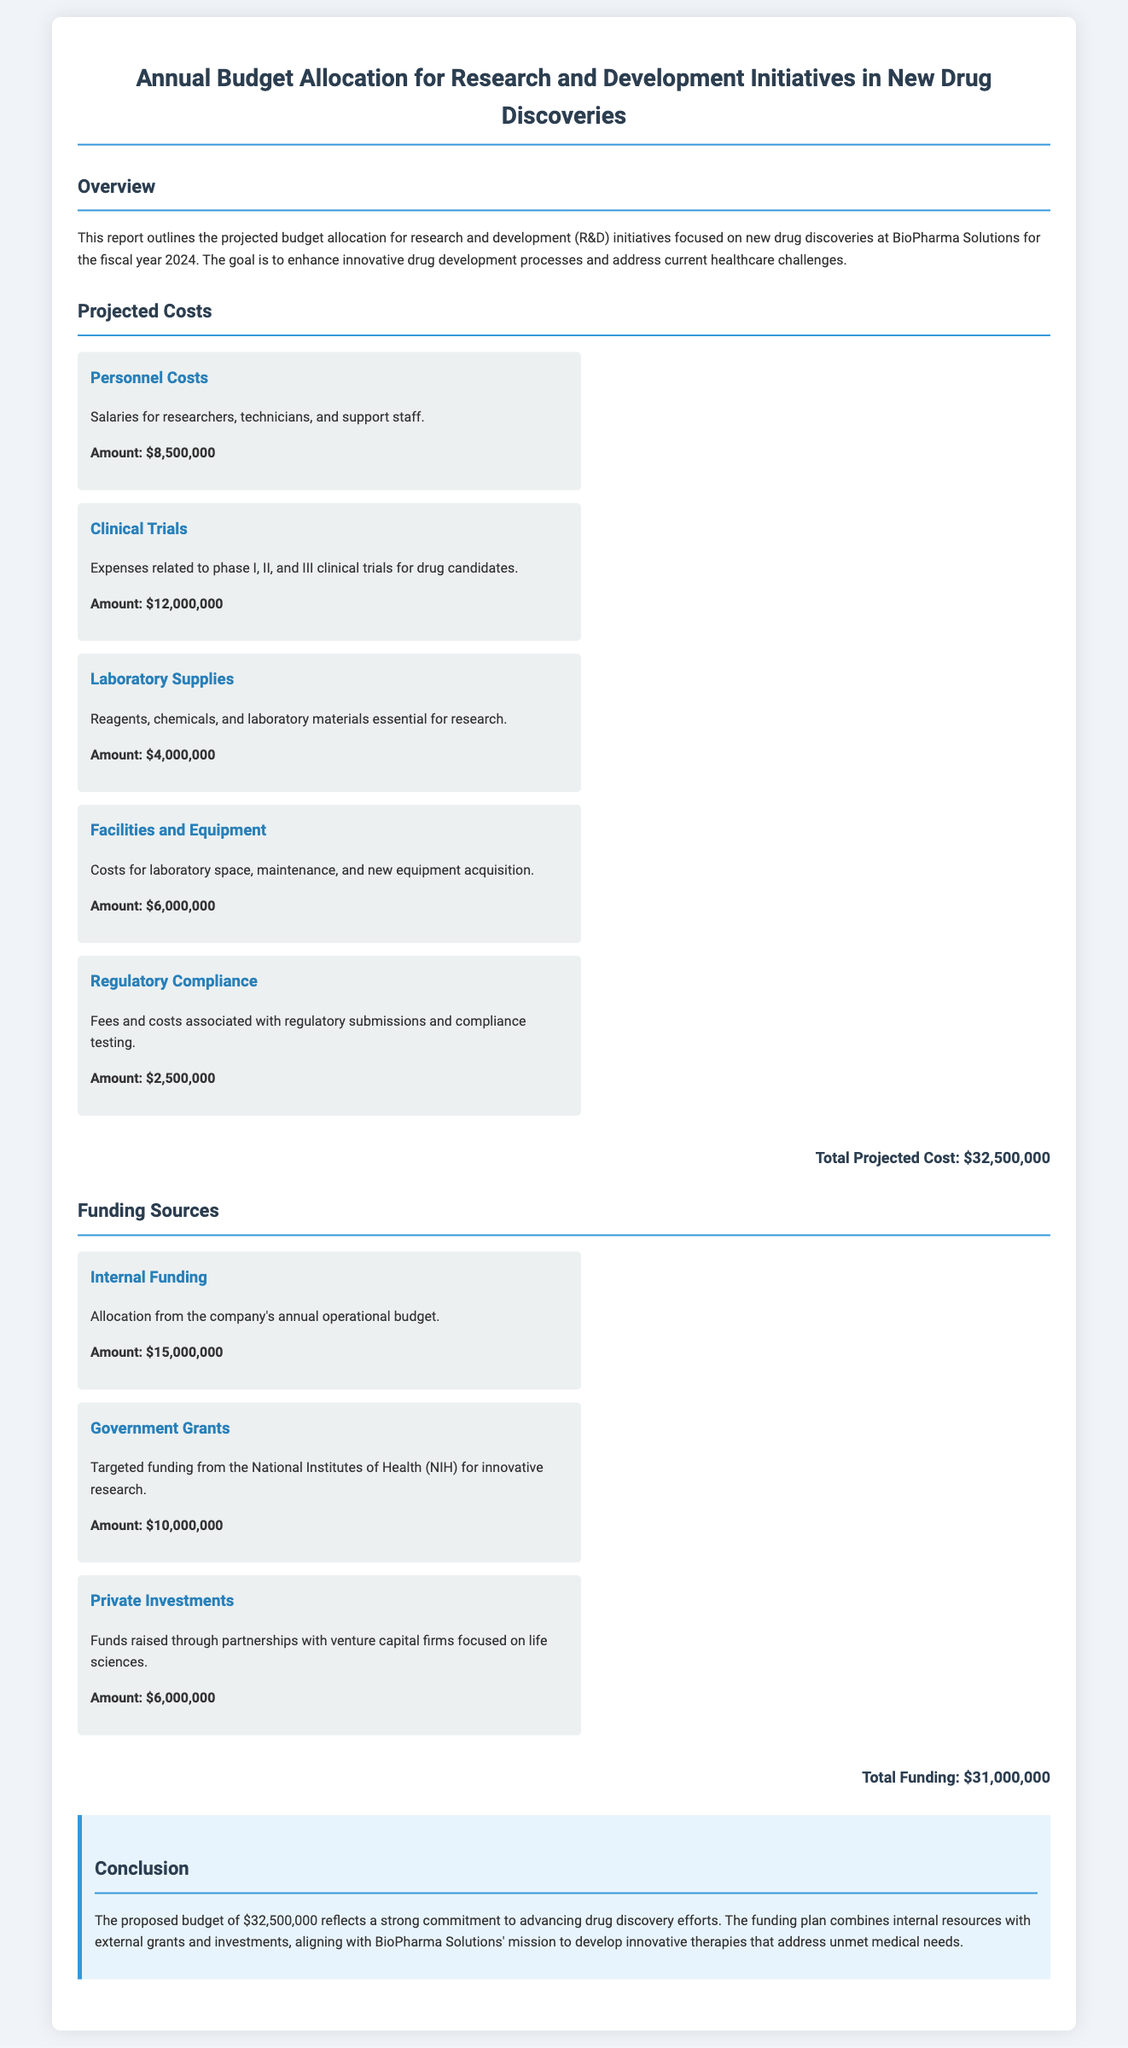What is the total projected cost? The total projected cost is calculated by summing all projected costs listed in the document, amounting to $32,500,000.
Answer: $32,500,000 What is the amount allocated for clinical trials? The amount allocated specifically for clinical trials is mentioned in the projected costs section of the document as $12,000,000.
Answer: $12,000,000 How much funding comes from government grants? The document states that targeted funding from government grants is $10,000,000.
Answer: $10,000,000 What are the total funding sources? The total funding sources are the sum of all funding amount indicated in the document, which is $15,000,000 + $10,000,000 + $6,000,000, resulting in $31,000,000.
Answer: $31,000,000 What is the amount for personnel costs? Personnel costs listed in the projected costs section are specifically identified as $8,500,000.
Answer: $8,500,000 Which funding source has the highest allocation? Among the funding sources, internal funding is stated as the highest allocation at $15,000,000.
Answer: Internal Funding What is the purpose of this R&D budget report? The purpose is outlined in the overview, stating it is focused on enhancing innovative drug development processes and addressing healthcare challenges.
Answer: Enhance innovative drug development What section discusses regulatory compliance costs? The projected costs section provides details about regulatory compliance costs, specifying it as an individual cost item.
Answer: Projected Costs What is the projected budget for laboratory supplies? The document specifies that the projected budget for laboratory supplies is $4,000,000.
Answer: $4,000,000 